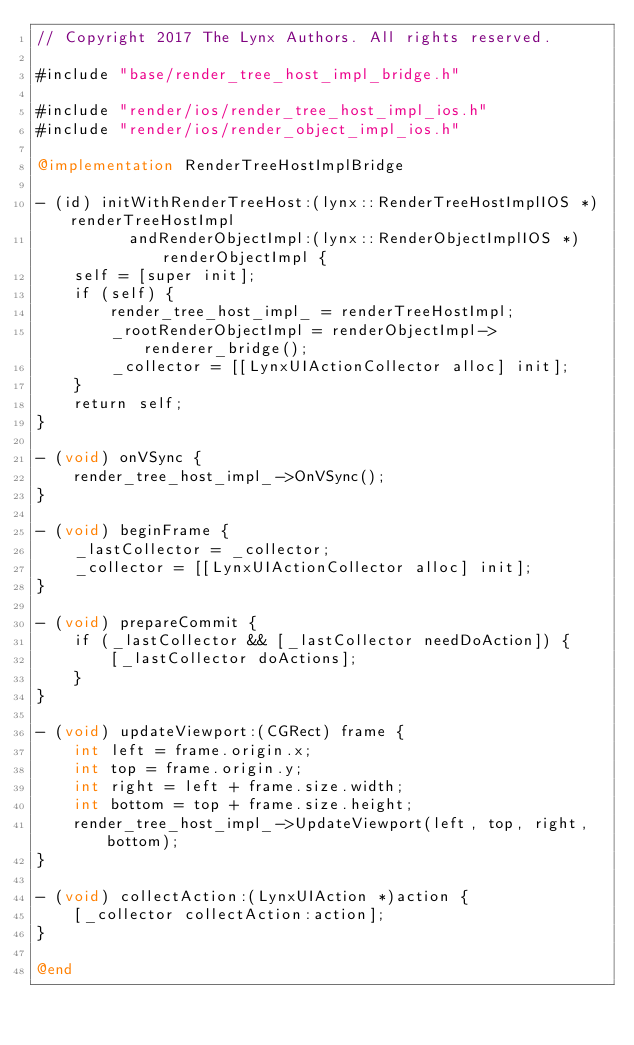<code> <loc_0><loc_0><loc_500><loc_500><_ObjectiveC_>// Copyright 2017 The Lynx Authors. All rights reserved.

#include "base/render_tree_host_impl_bridge.h"

#include "render/ios/render_tree_host_impl_ios.h"
#include "render/ios/render_object_impl_ios.h"

@implementation RenderTreeHostImplBridge

- (id) initWithRenderTreeHost:(lynx::RenderTreeHostImplIOS *) renderTreeHostImpl
          andRenderObjectImpl:(lynx::RenderObjectImplIOS *) renderObjectImpl {
    self = [super init];
    if (self) {
        render_tree_host_impl_ = renderTreeHostImpl;
        _rootRenderObjectImpl = renderObjectImpl->renderer_bridge();
        _collector = [[LynxUIActionCollector alloc] init];
    }
    return self;
}

- (void) onVSync {
    render_tree_host_impl_->OnVSync();
}

- (void) beginFrame {
    _lastCollector = _collector;
    _collector = [[LynxUIActionCollector alloc] init];
}

- (void) prepareCommit {
    if (_lastCollector && [_lastCollector needDoAction]) {
        [_lastCollector doActions];
    }
}

- (void) updateViewport:(CGRect) frame {
    int left = frame.origin.x;
    int top = frame.origin.y;
    int right = left + frame.size.width;
    int bottom = top + frame.size.height;
    render_tree_host_impl_->UpdateViewport(left, top, right, bottom);
}

- (void) collectAction:(LynxUIAction *)action {
    [_collector collectAction:action];
}

@end
</code> 